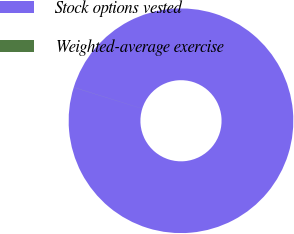Convert chart. <chart><loc_0><loc_0><loc_500><loc_500><pie_chart><fcel>Stock options vested<fcel>Weighted-average exercise<nl><fcel>99.99%<fcel>0.01%<nl></chart> 